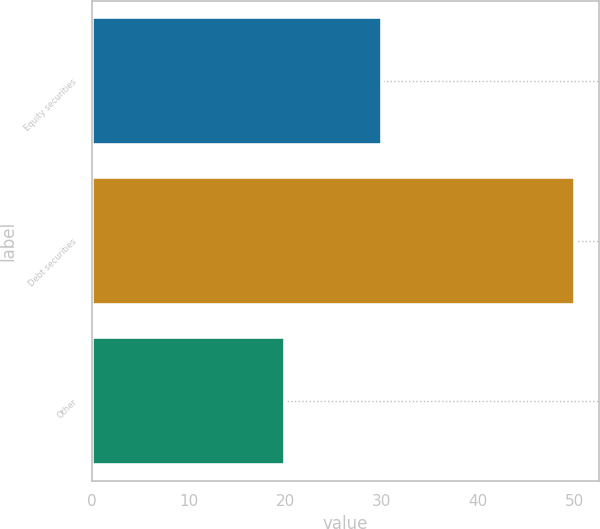Convert chart. <chart><loc_0><loc_0><loc_500><loc_500><bar_chart><fcel>Equity securities<fcel>Debt securities<fcel>Other<nl><fcel>30<fcel>50<fcel>20<nl></chart> 